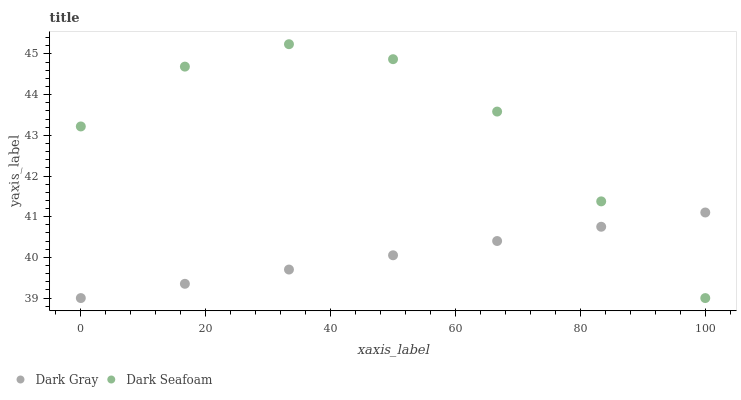Does Dark Gray have the minimum area under the curve?
Answer yes or no. Yes. Does Dark Seafoam have the maximum area under the curve?
Answer yes or no. Yes. Does Dark Seafoam have the minimum area under the curve?
Answer yes or no. No. Is Dark Gray the smoothest?
Answer yes or no. Yes. Is Dark Seafoam the roughest?
Answer yes or no. Yes. Is Dark Seafoam the smoothest?
Answer yes or no. No. Does Dark Gray have the lowest value?
Answer yes or no. Yes. Does Dark Seafoam have the highest value?
Answer yes or no. Yes. Does Dark Seafoam intersect Dark Gray?
Answer yes or no. Yes. Is Dark Seafoam less than Dark Gray?
Answer yes or no. No. Is Dark Seafoam greater than Dark Gray?
Answer yes or no. No. 